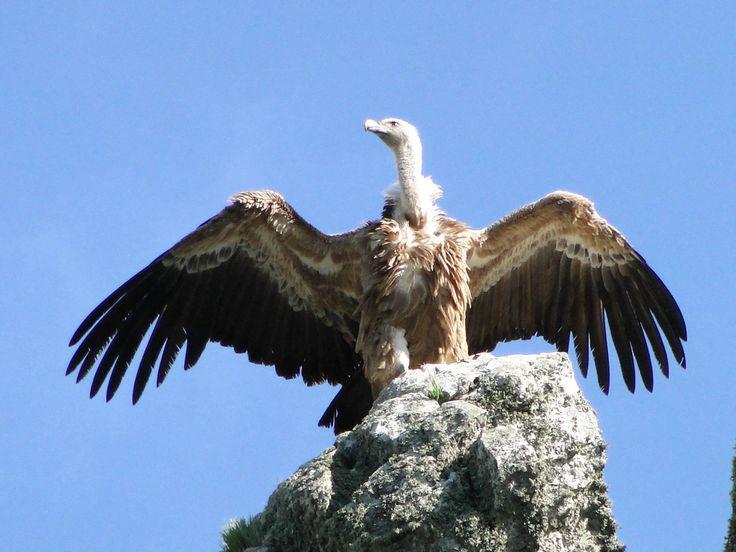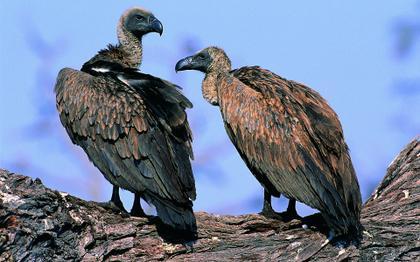The first image is the image on the left, the second image is the image on the right. Analyze the images presented: Is the assertion "There are three birds, two of which are facing left, and one of which is facing right." valid? Answer yes or no. Yes. The first image is the image on the left, the second image is the image on the right. Examine the images to the left and right. Is the description "There is a bird in flight not touching the ground." accurate? Answer yes or no. No. 